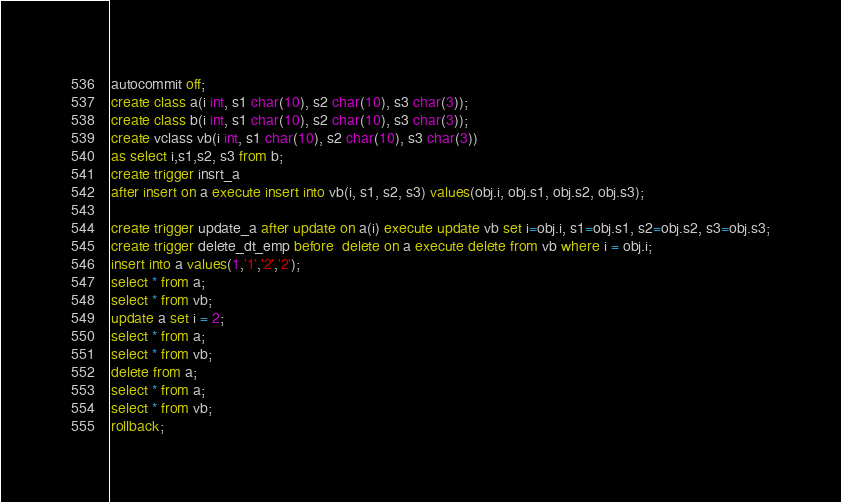Convert code to text. <code><loc_0><loc_0><loc_500><loc_500><_SQL_>autocommit off;
create class a(i int, s1 char(10), s2 char(10), s3 char(3));
create class b(i int, s1 char(10), s2 char(10), s3 char(3));
create vclass vb(i int, s1 char(10), s2 char(10), s3 char(3)) 
as select i,s1,s2, s3 from b;
create trigger insrt_a
after insert on a execute insert into vb(i, s1, s2, s3) values(obj.i, obj.s1, obj.s2, obj.s3);

create trigger update_a after update on a(i) execute update vb set i=obj.i, s1=obj.s1, s2=obj.s2, s3=obj.s3;
create trigger delete_dt_emp before  delete on a execute delete from vb where i = obj.i;
insert into a values(1,'1','2','2');
select * from a;
select * from vb;
update a set i = 2;
select * from a;
select * from vb;
delete from a;
select * from a;
select * from vb;
rollback;
</code> 